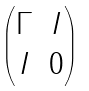Convert formula to latex. <formula><loc_0><loc_0><loc_500><loc_500>\begin{pmatrix} \Gamma & I \\ I & 0 \end{pmatrix}</formula> 